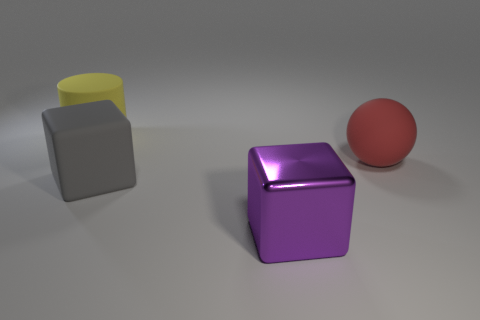What is the size of the rubber object that is both behind the big rubber cube and in front of the large yellow thing? The rubber object in question appears to be a medium-sized rubber ball. It is situated behind the large purple cube and in front of the partial view of what seems to be a large yellow cylinder. 